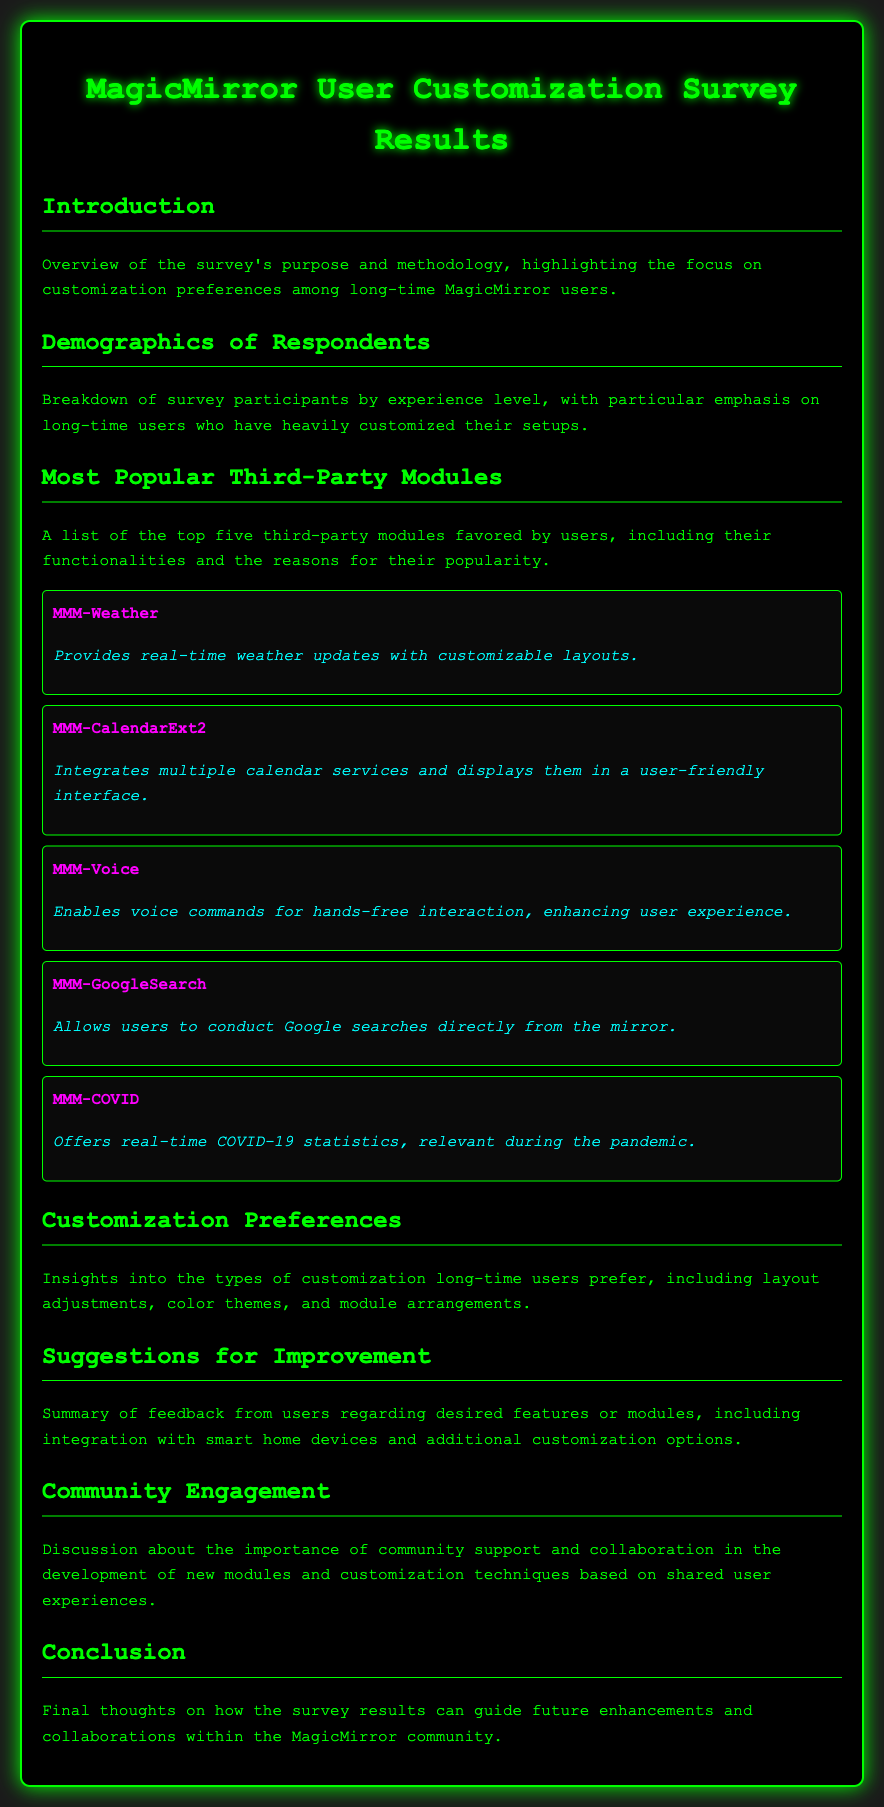What is the title of the document? The title is prominently displayed at the top of the document, indicating the survey results.
Answer: MagicMirror User Customization Survey Results How many third-party modules are listed as the most popular? The document mentions five specific third-party modules within the section discussing their popularity.
Answer: Five Which module provides real-time weather updates? The document specifies a particular module that focuses on delivering weather information.
Answer: MMM-Weather What is a common customization preference mentioned in the survey? The document discusses types of customizations preferred by long-time users, focusing on various aspects.
Answer: Layout adjustments What additional customization option do users desire? The document includes feedback regarding features or modules that users would like to see more of.
Answer: Smart home devices Which module allows users to conduct Google searches? The document identifies a specific module that facilitates searching through Google directly.
Answer: MMM-GoogleSearch What color theme is used for the document's design? The overall color scheme and text styling contribute to the document's visual appeal, as described in the style section.
Answer: Green on black What is emphasized in the Community Engagement section? The document highlights an important aspect regarding the community's role in developing modules.
Answer: Collaboration 